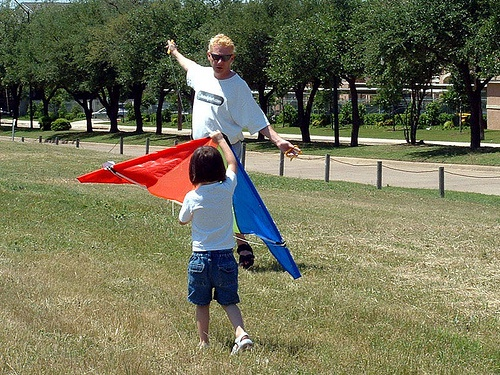Describe the objects in this image and their specific colors. I can see people in lightblue, black, gray, and white tones, kite in lightblue, blue, salmon, red, and brown tones, people in lightblue, white, gray, darkgray, and black tones, and car in lightblue, gray, black, white, and darkgray tones in this image. 